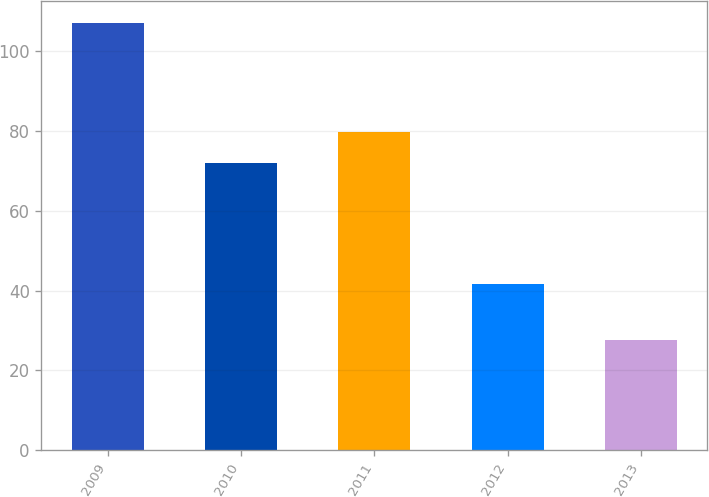Convert chart to OTSL. <chart><loc_0><loc_0><loc_500><loc_500><bar_chart><fcel>2009<fcel>2010<fcel>2011<fcel>2012<fcel>2013<nl><fcel>107.2<fcel>71.9<fcel>79.87<fcel>41.7<fcel>27.5<nl></chart> 